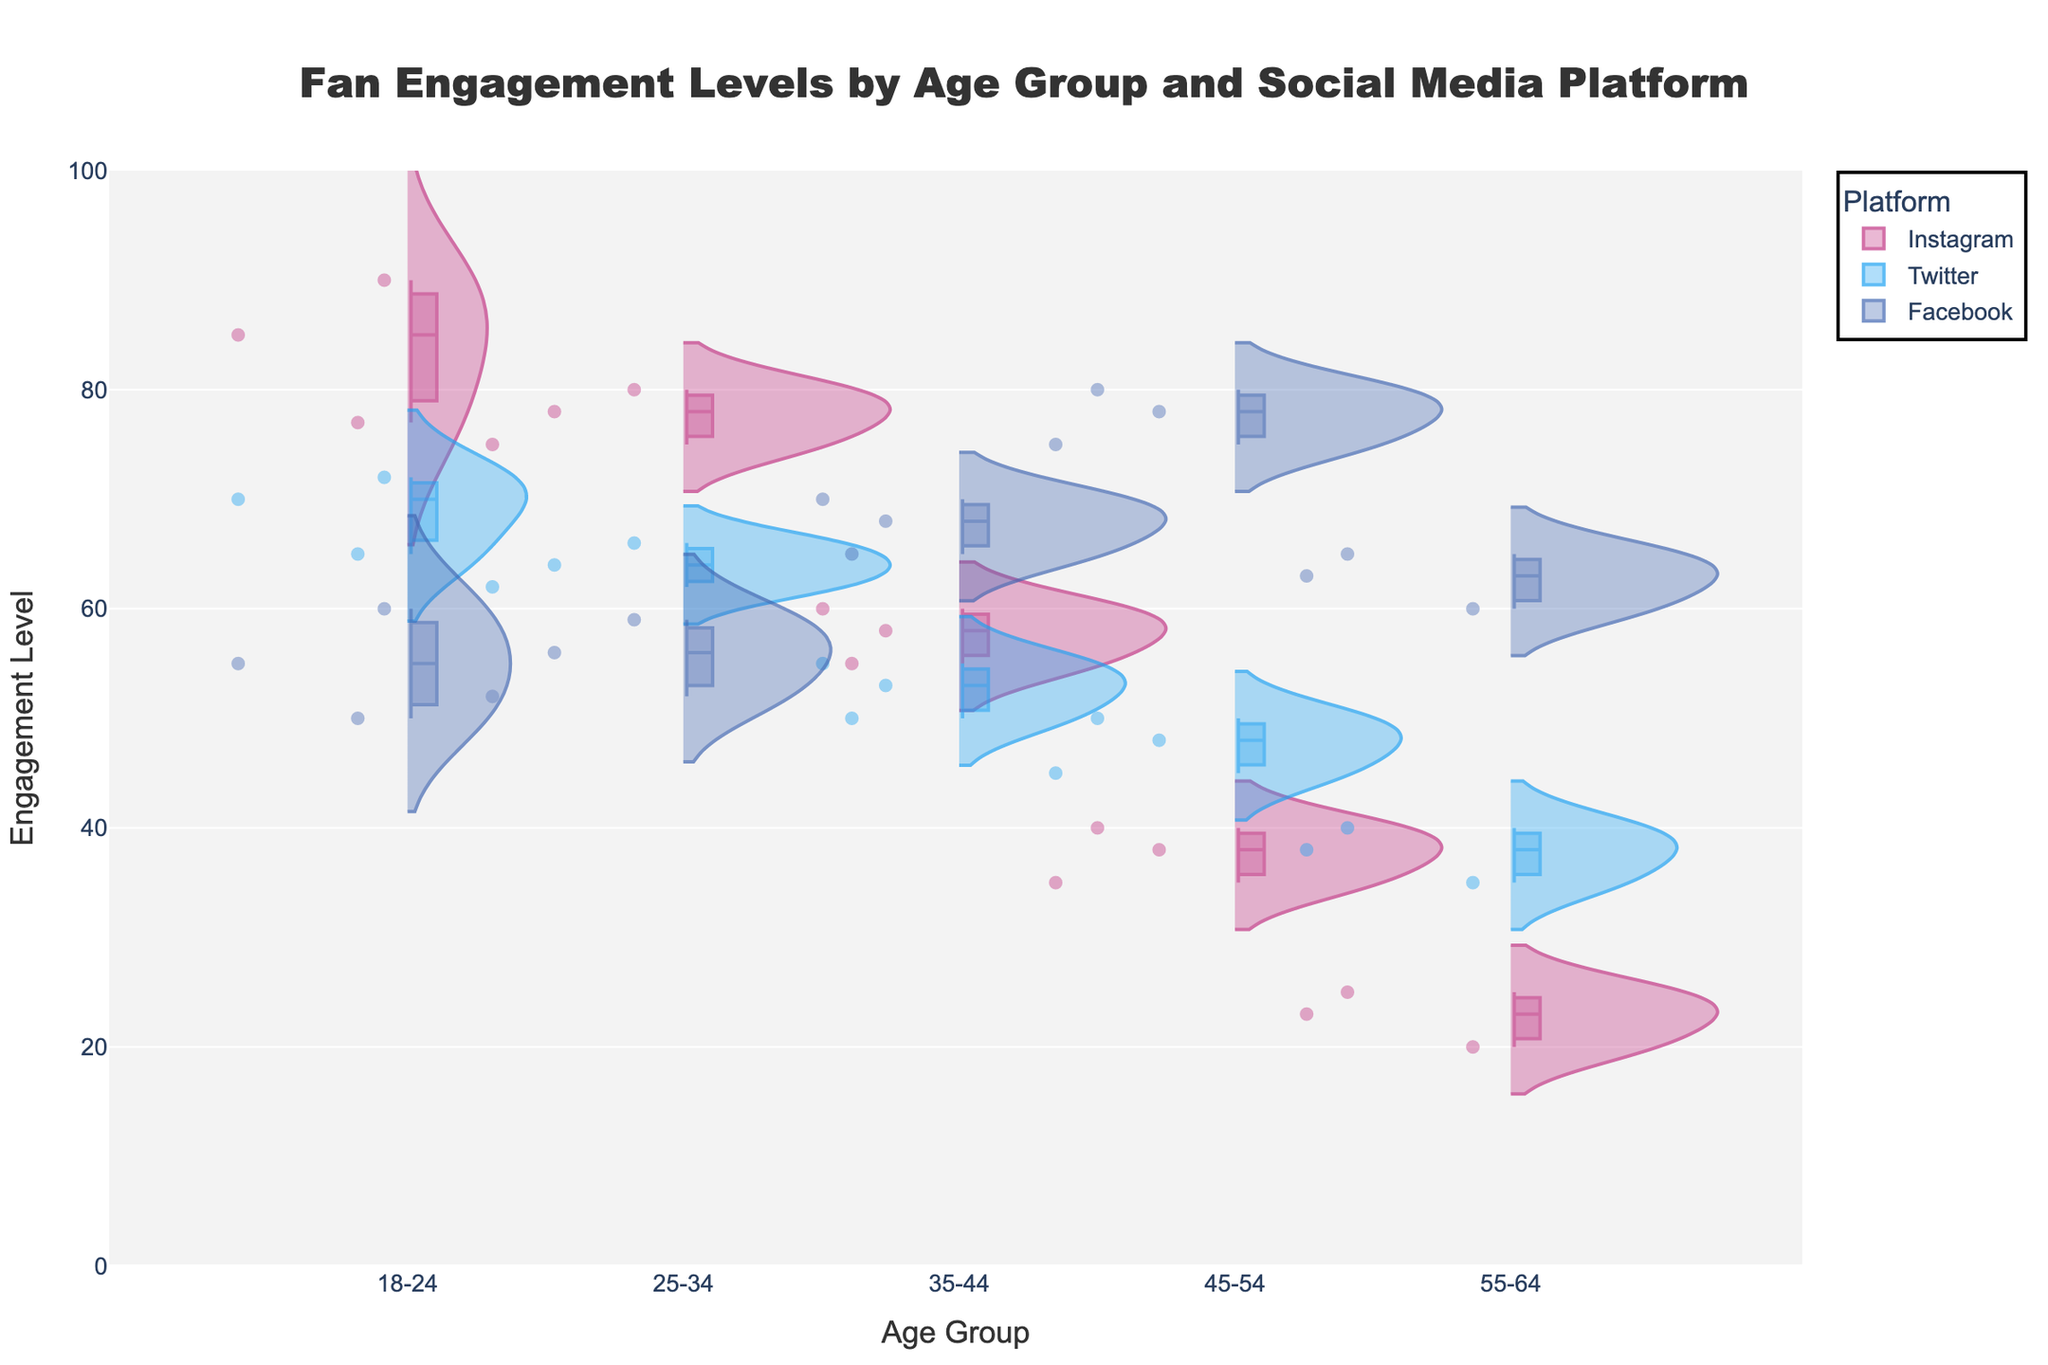What's the title of the figure? The title is usually placed at the top center part of the chart and it summarizes what the chart is about.
Answer: "Fan Engagement Levels by Age Group and Social Media Platform" Which social media platform shows the highest engagement level for the 18-24 age group? To determine the highest engagement level for the 18-24 age group, look at the data points for all platforms under this age group and identify the highest value.
Answer: Instagram What is the median engagement level for Twitter in the 25-34 age group? The median engagement level is represented by the box in the violin plot. For the Twitter data points under the 25-34 age group, find the middle value.
Answer: 64 Between Instagram and Facebook, which social media platform has a wider distribution of engagement levels for the 35-44 age group? To find the wider distribution, compare the spread (range from minimum to maximum) of the two platforms within the 35-44 age group.
Answer: Facebook What is the average engagement level for Instagram across all age groups? First, sum up all the engagement levels for Instagram and then divide by the number of data points. Instagram data points are [85, 90, 77, 75, 80, 78, 55, 60, 58, 35, 40, 38, 20, 25, 23]. Sum = 839. Number of data points = 15. Average = 839/15.
Answer: 55.93 Which age group has the lowest median engagement level on Facebook? The median engagement level is shown by the middle point of the box in each Facebook distribution. Compare the median values across age groups to find the lowest.
Answer: 18-24 Is there any age group where the engagement level on Twitter is consistently below 50? Check all the data points for each age group under Twitter and see if any age group has all points below 50.
Answer: No How do the engagement levels for Facebook vary across age groups? Observe the distribution for Facebook across different age groups. Note the shape and spread of each violin plot and the position of the median line.
Answer: Engagement levels increase with age For which age group is the range of engagement levels on Instagram the smallest? Determine the range (difference between maximum and minimum engagement levels) for Instagram in each age group, then find the smallest.
Answer: 45-54 Which social media platform shows the most significant drop in engagement levels as age increases? Compare the average engagement levels for each platform across different age groups. Note the trend for each platform to identify the one with the steepest decline.
Answer: Instagram 